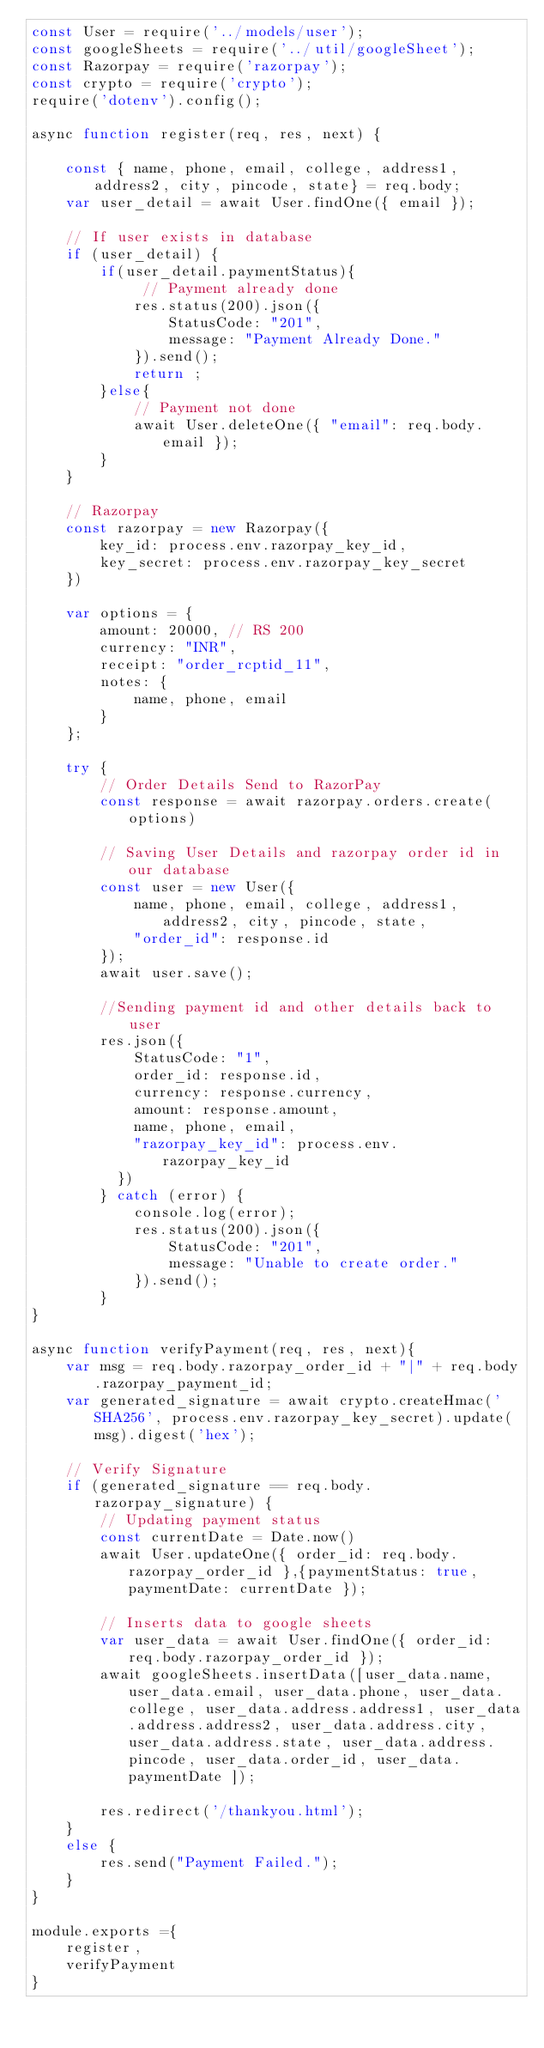<code> <loc_0><loc_0><loc_500><loc_500><_JavaScript_>const User = require('../models/user');
const googleSheets = require('../util/googleSheet');
const Razorpay = require('razorpay');
const crypto = require('crypto');
require('dotenv').config();

async function register(req, res, next) {

    const { name, phone, email, college, address1, address2, city, pincode, state} = req.body;
    var user_detail = await User.findOne({ email });

    // If user exists in database
    if (user_detail) {
        if(user_detail.paymentStatus){
             // Payment already done 
            res.status(200).json({
                StatusCode: "201",
                message: "Payment Already Done."
            }).send();
            return ;
        }else{ 
            // Payment not done
            await User.deleteOne({ "email": req.body.email });
        }
    }

    // Razorpay
    const razorpay = new Razorpay({
        key_id: process.env.razorpay_key_id,
        key_secret: process.env.razorpay_key_secret
    })
    
    var options = {
        amount: 20000, // RS 200
        currency: "INR",
        receipt: "order_rcptid_11",
        notes: { 
            name, phone, email
        }
    };
        
    try {
        // Order Details Send to RazorPay
        const response = await razorpay.orders.create(options)

        // Saving User Details and razorpay order id in our database
        const user = new User({
            name, phone, email, college, address1, address2, city, pincode, state,
            "order_id": response.id
        });
        await user.save();

        //Sending payment id and other details back to user
        res.json({
            StatusCode: "1",
            order_id: response.id,
            currency: response.currency,
            amount: response.amount,
            name, phone, email,
            "razorpay_key_id": process.env.razorpay_key_id
          })
        } catch (error) {
            console.log(error);
            res.status(200).json({
                StatusCode: "201",
                message: "Unable to create order."
            }).send();
        }
}

async function verifyPayment(req, res, next){
    var msg = req.body.razorpay_order_id + "|" + req.body.razorpay_payment_id;
    var generated_signature = await crypto.createHmac('SHA256', process.env.razorpay_key_secret).update(msg).digest('hex');

    // Verify Signature
    if (generated_signature == req.body.razorpay_signature) {
        // Updating payment status
        const currentDate = Date.now()
        await User.updateOne({ order_id: req.body.razorpay_order_id },{paymentStatus: true, paymentDate: currentDate });

        // Inserts data to google sheets
        var user_data = await User.findOne({ order_id: req.body.razorpay_order_id });
        await googleSheets.insertData([user_data.name, user_data.email, user_data.phone, user_data.college, user_data.address.address1, user_data.address.address2, user_data.address.city, user_data.address.state, user_data.address.pincode, user_data.order_id, user_data.paymentDate ]);

        res.redirect('/thankyou.html');
    }
    else {
        res.send("Payment Failed.");
    }
}

module.exports ={
    register,
    verifyPayment
}</code> 